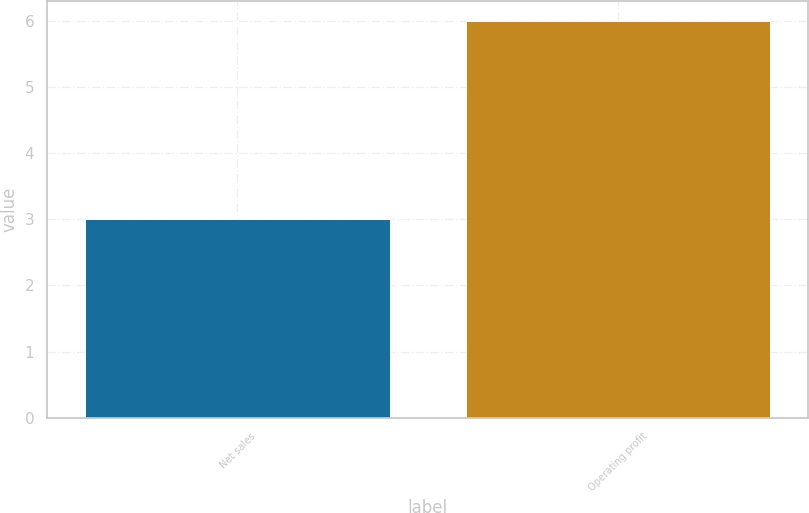Convert chart to OTSL. <chart><loc_0><loc_0><loc_500><loc_500><bar_chart><fcel>Net sales<fcel>Operating profit<nl><fcel>3<fcel>6<nl></chart> 